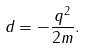<formula> <loc_0><loc_0><loc_500><loc_500>d = - \frac { q ^ { 2 } } { 2 m } .</formula> 